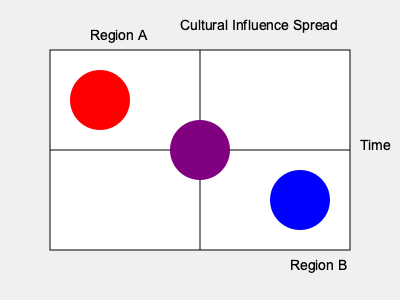Based on the color-coded map depicting cultural influence spread over time between Region A and Region B, what can be inferred about the nature of cultural exchange in the central area? How might this interpretation inform your approach to writing historical fiction set in this region? To interpret the cultural influence spread depicted in the map, we need to analyze it step-by-step:

1. Color representation:
   - Red circle: represents the cultural influence of Region A
   - Blue circle: represents the cultural influence of Region B
   - Purple circle: represents a mixture of both cultures

2. Spatial arrangement:
   - The red circle is in the top-left quadrant, closer to Region A
   - The blue circle is in the bottom-right quadrant, closer to Region B
   - The purple circle is in the center

3. Temporal interpretation:
   - The x-axis represents time, moving from left to right
   - The central position of the purple circle suggests a midpoint in the timeline

4. Cultural spread analysis:
   - The red and blue circles indicate distinct cultural influences in their respective regions
   - The purple circle in the center represents a blending of both cultures over time

5. Interpretation for historical fiction:
   - The central area likely represents a melting pot of cultures from both regions
   - Characters from this area would likely exhibit traits and customs from both cultures
   - The setting would reflect a gradual merging of architectural styles, social norms, and traditions
   - Conflicts and resolutions in the story could stem from the interaction between these blended cultures

6. Writing approach:
   - Develop characters that embody aspects of both cultures
   - Create a setting that visually and socially represents the merging of the two influences
   - Explore themes of cultural identity, adaptation, and the challenges of cultural integration
   - Use historical events or figures from both regions to add depth and authenticity to the narrative
Answer: Cultural hybridization in the central area, informing character development, setting design, and thematic exploration in historical fiction writing. 